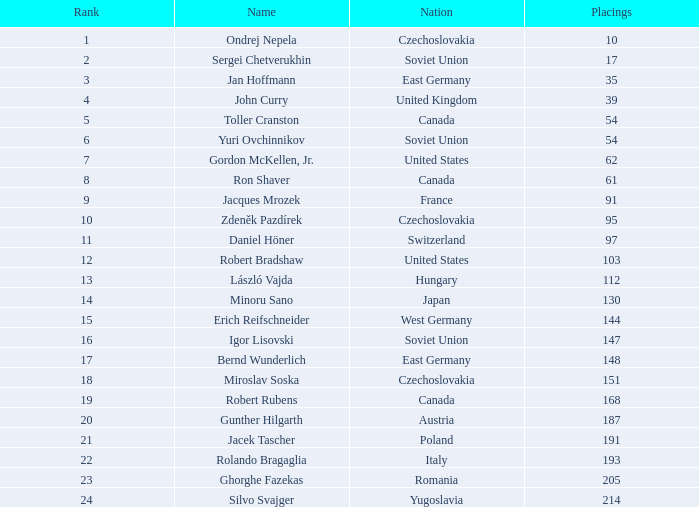Which Placings have a Nation of west germany, and Points larger than 303.72? None. 